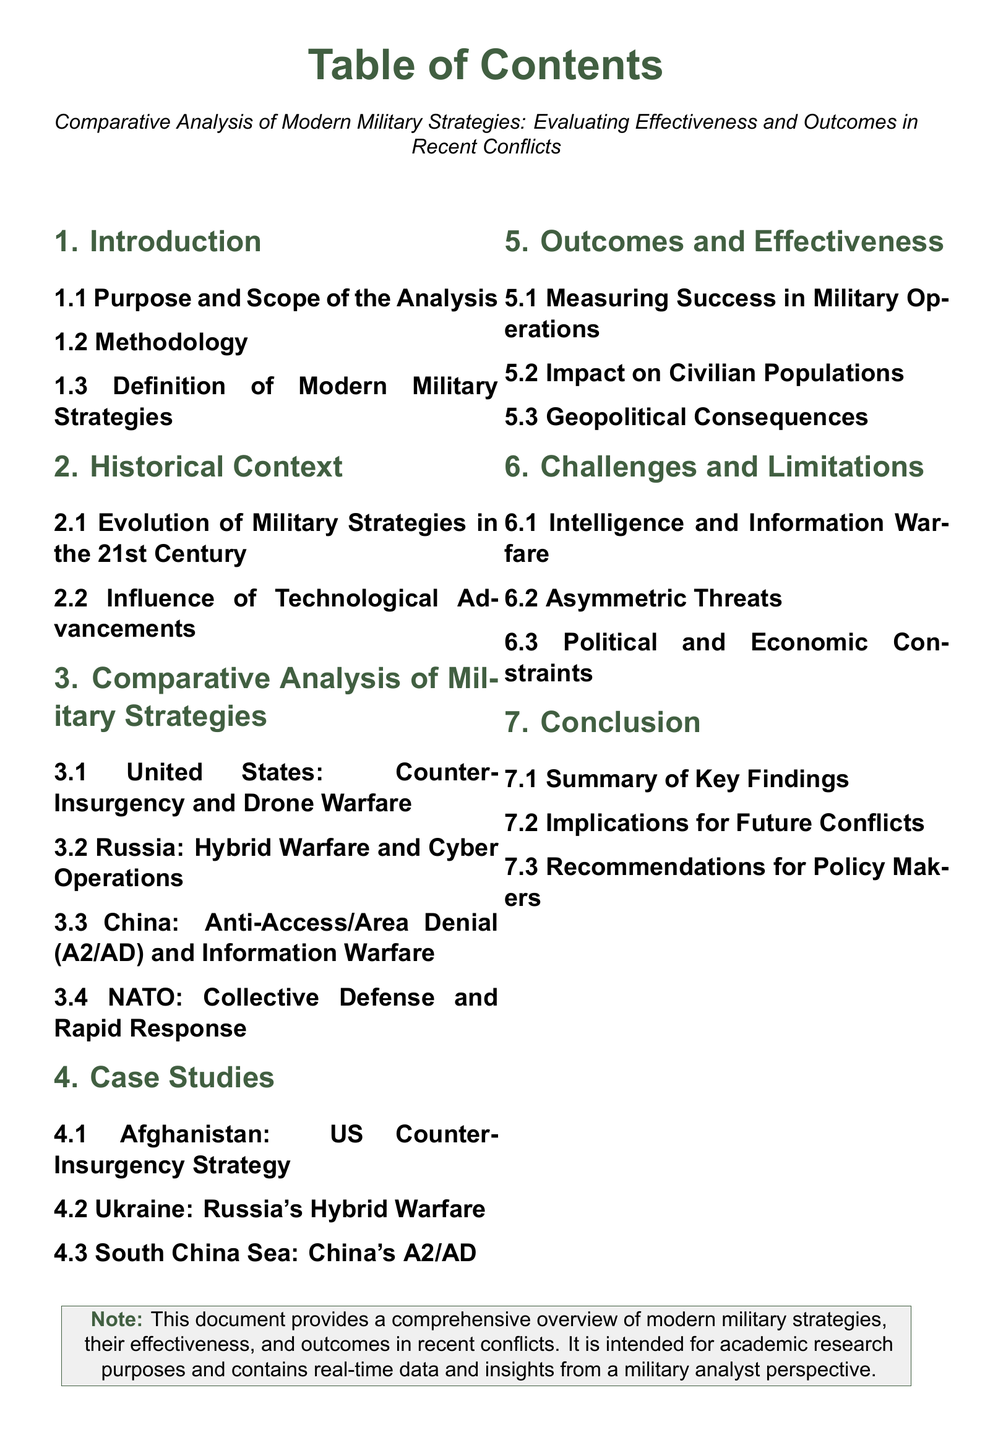What is the title of the document? The title is presented prominently at the top of the Table of Contents.
Answer: Comparative Analysis of Modern Military Strategies: Evaluating Effectiveness and Outcomes in Recent Conflicts How many sections are there in the Table of Contents? The total number of sections outlined is counted in the Table of Contents.
Answer: 7 What is the focus of Section 3? Section 3 is dedicated to analyzing various military strategies comparatively.
Answer: Comparative Analysis of Military Strategies Which country is associated with Anti-Access/Area Denial strategy? The country implementing this strategy is specified in the Case Studies section.
Answer: China What does Section 5 primarily measure? Section 5 discusses the criteria for success in military operations.
Answer: Measuring Success in Military Operations What does the document note is intended for? The intended purpose of the document is explicitly stated in the note at the bottom.
Answer: Academic research purposes Name one of the challenges mentioned in Section 6. A challenge discussed in Section 6 relates to threats encountered in modern military contexts.
Answer: Asymmetric Threats 